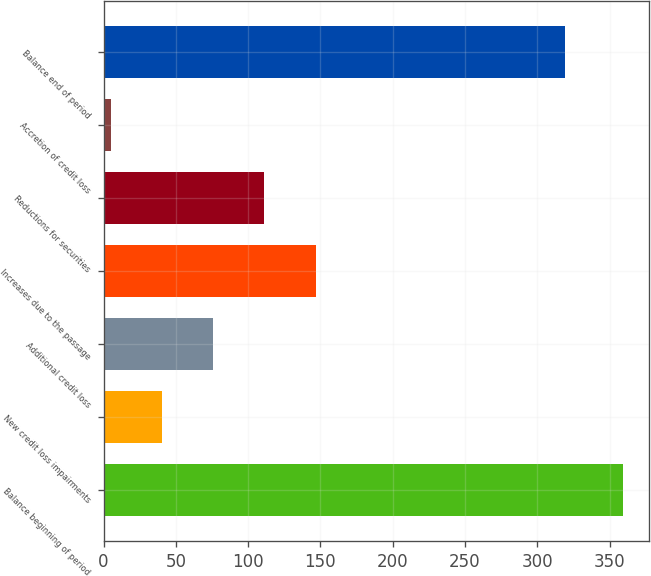Convert chart. <chart><loc_0><loc_0><loc_500><loc_500><bar_chart><fcel>Balance beginning of period<fcel>New credit loss impairments<fcel>Additional credit loss<fcel>Increases due to the passage<fcel>Reductions for securities<fcel>Accretion of credit loss<fcel>Balance end of period<nl><fcel>359<fcel>40.4<fcel>75.8<fcel>146.6<fcel>111.2<fcel>5<fcel>319<nl></chart> 